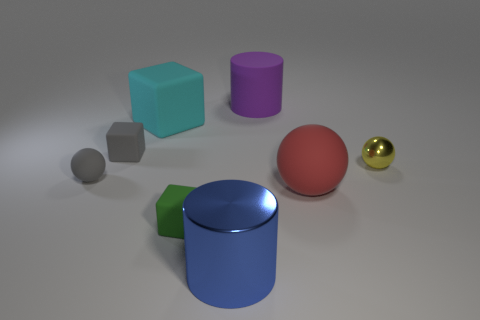Subtract all big red rubber spheres. How many spheres are left? 2 Add 2 yellow shiny spheres. How many objects exist? 10 Subtract all spheres. How many objects are left? 5 Add 5 yellow cubes. How many yellow cubes exist? 5 Subtract 0 cyan spheres. How many objects are left? 8 Subtract all cyan balls. Subtract all cyan cylinders. How many balls are left? 3 Subtract all gray objects. Subtract all large red matte spheres. How many objects are left? 5 Add 7 green blocks. How many green blocks are left? 8 